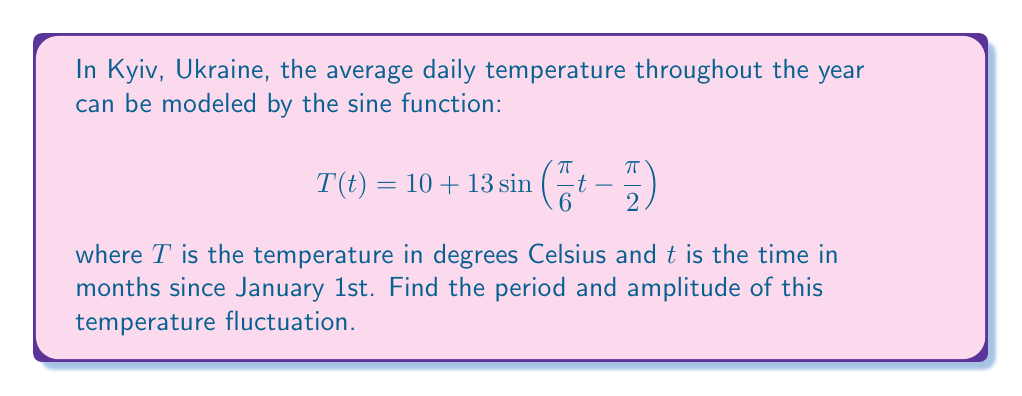What is the answer to this math problem? To find the period and amplitude of this sine wave, we need to analyze the given function:

$$T(t) = 10 + 13\sin\left(\frac{\pi}{6}t - \frac{\pi}{2}\right)$$

1. Amplitude:
   The amplitude is the maximum deviation from the midline of the sine wave. In the general form $a\sin(bt + c) + d$, the amplitude is |a|.
   Here, the coefficient of sine is 13, so the amplitude is 13°C.

2. Period:
   The period of a sine function in the form $\sin(bt + c)$ is given by $\frac{2\pi}{|b|}$.
   In our function, $b = \frac{\pi}{6}$.
   
   Period = $\frac{2\pi}{|\frac{\pi}{6}|} = \frac{2\pi}{\frac{\pi}{6}} = 2 \cdot 6 = 12$ months

   This makes sense as we expect the temperature to complete one full cycle over a year.
Answer: Amplitude: 13°C, Period: 12 months 